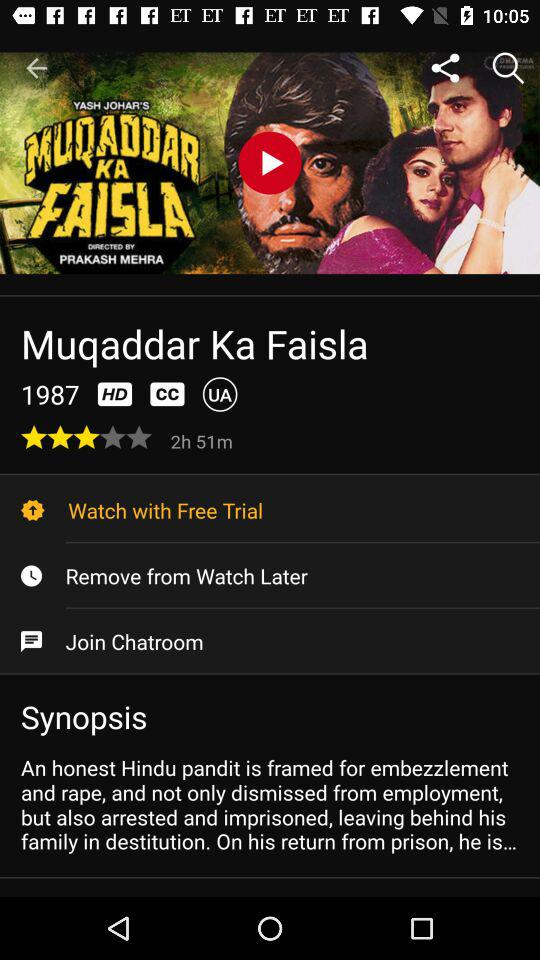What is the duration of the movie? The duration of the movie is 2 hours 51 minutes. 